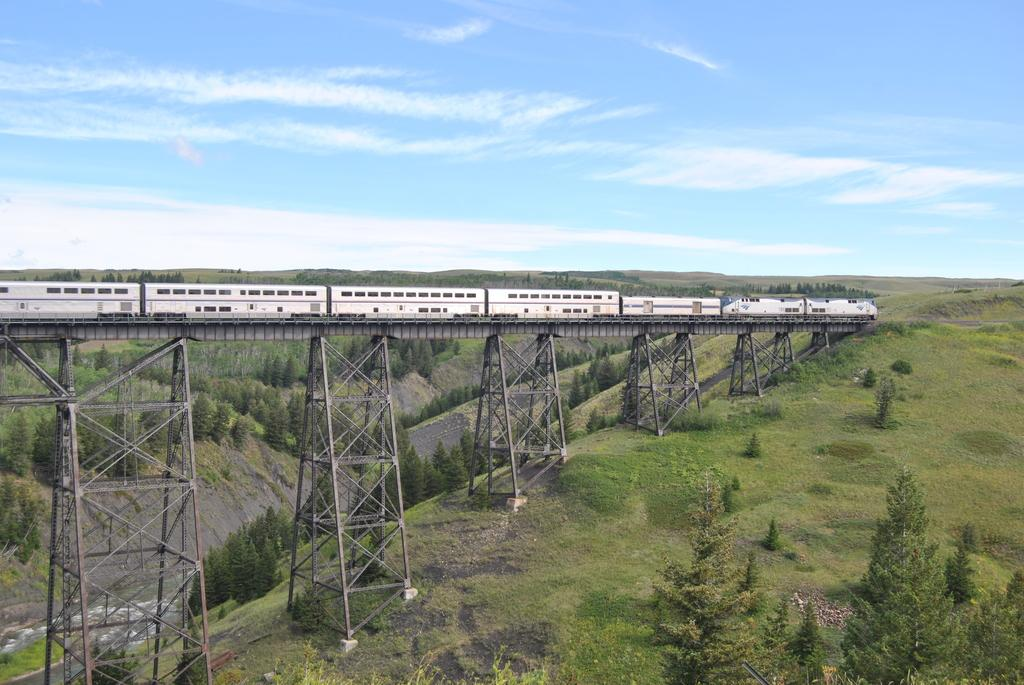What is the main subject of the image? The main subject of the image is a train on the railway track. What other structures or objects can be seen in the image? There is a bridge and grills present in the image. What type of vegetation is visible in the image? There are trees in the image. What is visible in the background of the image? The sky is visible in the image, and clouds are present in the sky. What type of discussion is taking place between the bears in the image? There are no bears present in the image, so no discussion can be observed. Who is teaching the students in the image? There are no students or teaching activity present in the image. 